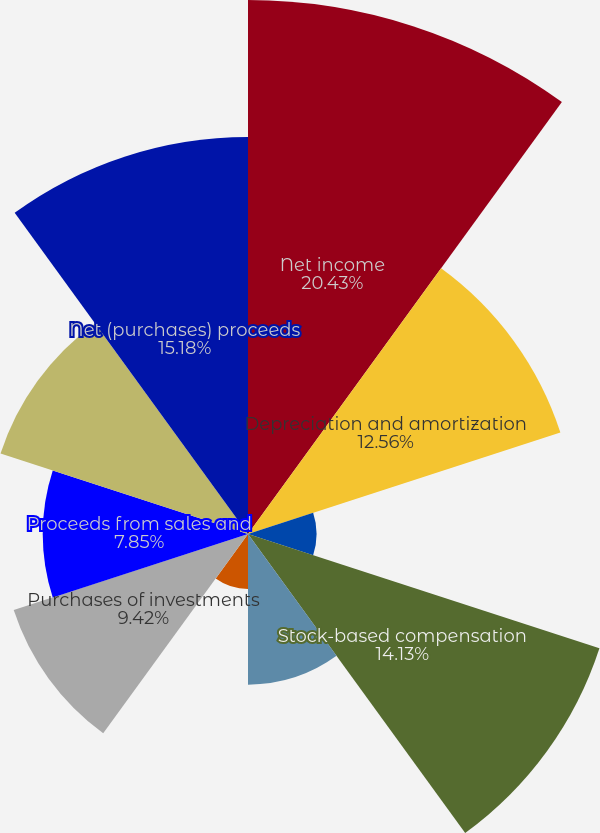Convert chart to OTSL. <chart><loc_0><loc_0><loc_500><loc_500><pie_chart><fcel>Net income<fcel>Depreciation and amortization<fcel>Amortization of deferred sales<fcel>Stock-based compensation<fcel>Deferred income tax expense<fcel>Net (gains) losses on<fcel>Purchases of investments<fcel>Proceeds from sales and<fcel>Change in cash and cash<fcel>Net (purchases) proceeds<nl><fcel>20.42%<fcel>12.56%<fcel>2.62%<fcel>14.13%<fcel>5.76%<fcel>2.1%<fcel>9.42%<fcel>7.85%<fcel>9.95%<fcel>15.18%<nl></chart> 